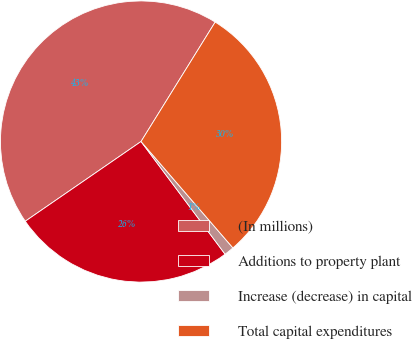Convert chart to OTSL. <chart><loc_0><loc_0><loc_500><loc_500><pie_chart><fcel>(In millions)<fcel>Additions to property plant<fcel>Increase (decrease) in capital<fcel>Total capital expenditures<nl><fcel>43.44%<fcel>25.6%<fcel>1.14%<fcel>29.82%<nl></chart> 